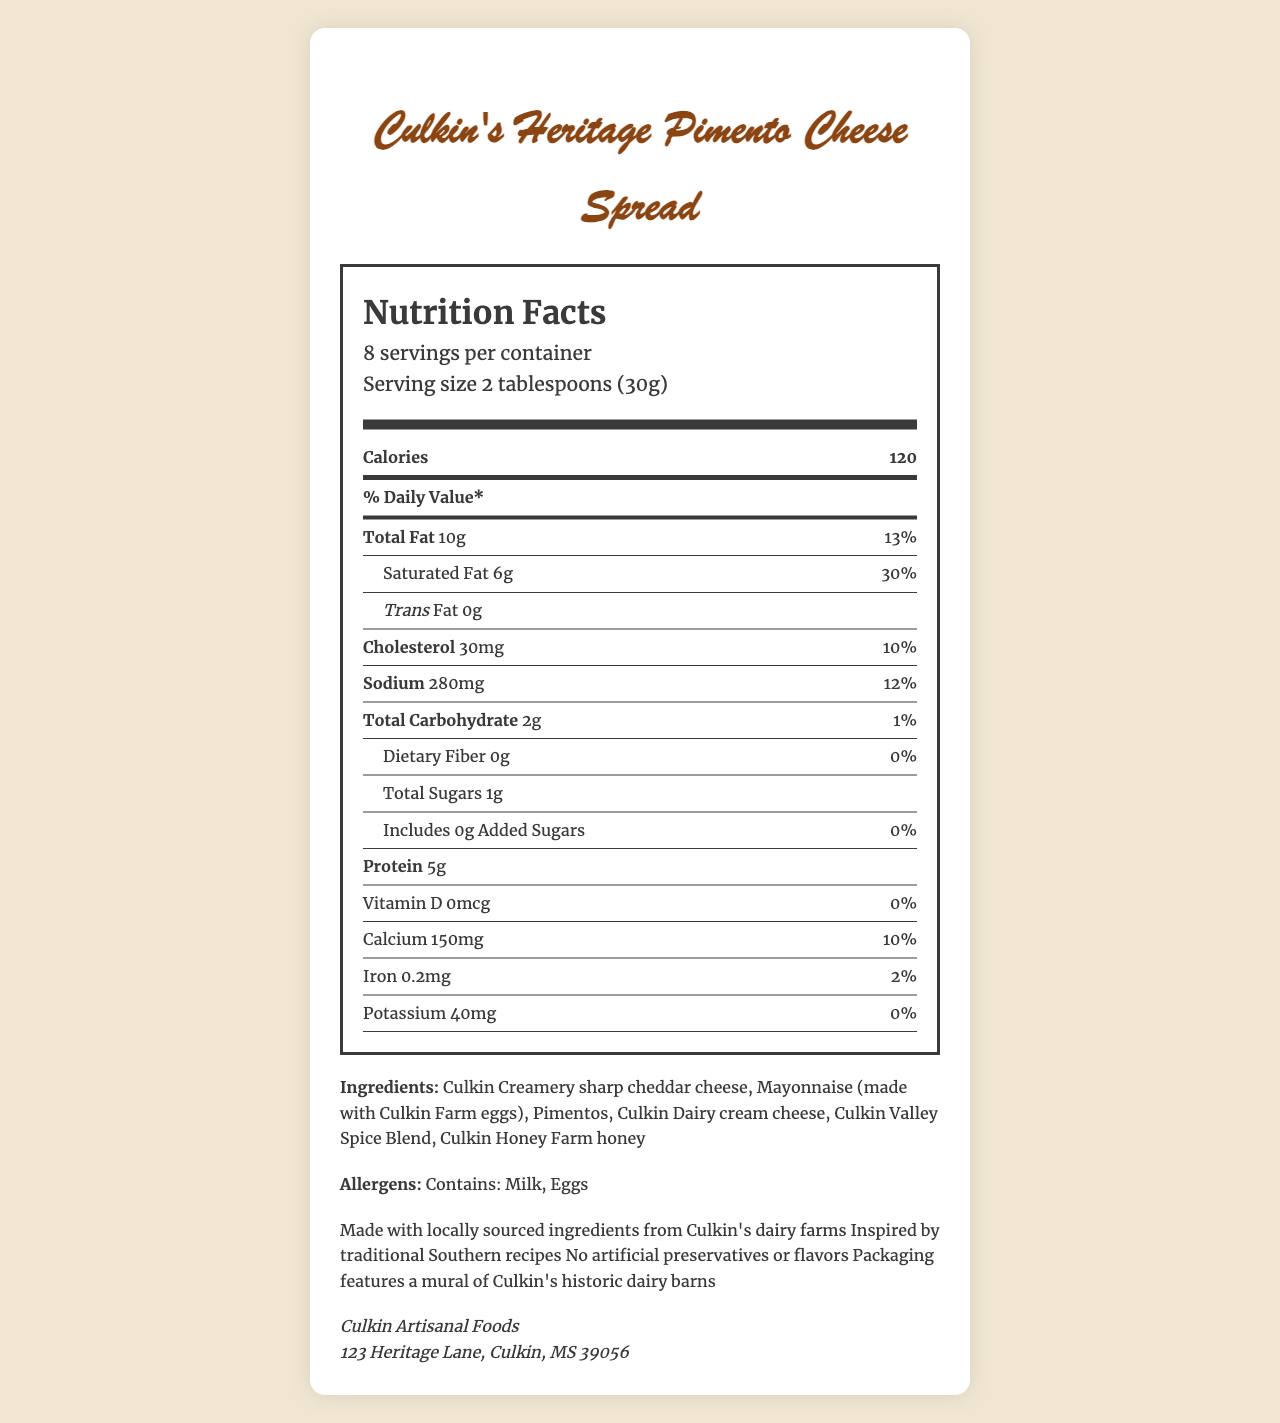what is the serving size? The serving size is indicated right below the "serving info" section on the Nutrition Facts label.
Answer: 2 tablespoons (30g) how many servings are in the container? This information is provided under the "serving info" section on the label.
Answer: 8 servings what is the total fat content per serving? The total fat content per serving is listed in the "Total Fat" row in the Nutrition Facts panel.
Answer: 10g how much calcium is in one serving, and what percentage of the daily value does it represent? This information is found in the "Calcium" row towards the bottom of the Nutrition Facts panel.
Answer: 150mg, 10% what allergens are contained in this product? The allergens are listed under the "Allergens" section in the document.
Answer: Milk, Eggs Is Culkin's Heritage Pimento Cheese Spread a good source of protein? Yes/No One serving of the cheese spread contains 5g of protein, which qualifies it as a source of protein.
Answer: Yes how many calories are there per serving? This information is provided in bold at the top of the Nutrition Facts label.
Answer: 120 calories which ingredient is listed first in the ingredients list? The ingredients list shows Culkin Creamery sharp cheddar cheese as the first ingredient.
Answer: Culkin Creamery sharp cheddar cheese which of the following nutrients is not present in significant amounts per serving? A. Iron B. Calcium C. Vitamin D D. Sodium Vitamin D has 0% of the daily value, indicating it is present in insignificant amounts.
Answer: C what percentage of the daily value does the saturated fat provide? A. 10% B. 13% C. 30% For saturated fat, the daily value percentage provided is 30%.
Answer: C are there any added sugars in this product? The label indicates that the product includes 0g of added sugars, which means there are no added sugars.
Answer: No where is Culkin's Heritage Pimento Cheese Spread manufactured? This information is given at the bottom under the manufacturer’s details.
Answer: 123 Heritage Lane, Culkin, MS 39056 what is the amount of sodium in one serving? The sodium amount per serving is listed in the middle of the Nutrition Facts label.
Answer: 280mg describe the additional information provided about this product The additional information section provides details about the sourcing of ingredients, inspiration behind the recipe, absence of artificial ingredients, and the unique packaging design.
Answer: The product is made with locally sourced ingredients from Culkin's dairy farms, inspired by traditional Southern recipes, contains no artificial preservatives or flavors, and the packaging features a mural of Culkin's historic dairy barns. what is the amount of dietary fiber in one serving? The amount of dietary fiber is listed as 0g in the Nutrition Facts panel.
Answer: 0g How many calories are derived from fat per serving? The document does not provide information on the amount of calories derived from fat, only the total number of calories and fat content.
Answer: Cannot be determined 